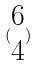<formula> <loc_0><loc_0><loc_500><loc_500>( \begin{matrix} 6 \\ 4 \end{matrix} )</formula> 